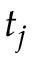Convert formula to latex. <formula><loc_0><loc_0><loc_500><loc_500>t _ { j }</formula> 